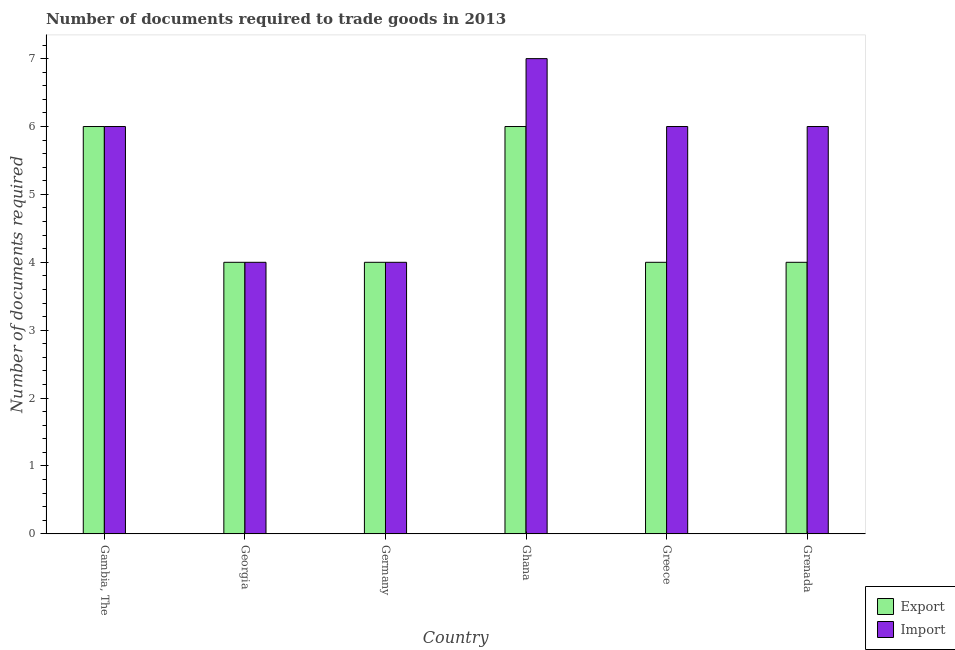How many different coloured bars are there?
Offer a very short reply. 2. Are the number of bars per tick equal to the number of legend labels?
Give a very brief answer. Yes. How many bars are there on the 2nd tick from the right?
Give a very brief answer. 2. What is the label of the 5th group of bars from the left?
Give a very brief answer. Greece. In how many cases, is the number of bars for a given country not equal to the number of legend labels?
Keep it short and to the point. 0. In which country was the number of documents required to export goods maximum?
Keep it short and to the point. Gambia, The. In which country was the number of documents required to import goods minimum?
Offer a terse response. Georgia. What is the difference between the number of documents required to import goods in Gambia, The and the number of documents required to export goods in Greece?
Make the answer very short. 2. What is the average number of documents required to export goods per country?
Your answer should be compact. 4.67. What is the difference between the number of documents required to import goods and number of documents required to export goods in Ghana?
Offer a very short reply. 1. In how many countries, is the number of documents required to import goods greater than 3.6 ?
Offer a terse response. 6. Is the number of documents required to import goods in Germany less than that in Ghana?
Your answer should be compact. Yes. Is the difference between the number of documents required to export goods in Ghana and Grenada greater than the difference between the number of documents required to import goods in Ghana and Grenada?
Give a very brief answer. Yes. In how many countries, is the number of documents required to export goods greater than the average number of documents required to export goods taken over all countries?
Provide a succinct answer. 2. Is the sum of the number of documents required to export goods in Gambia, The and Grenada greater than the maximum number of documents required to import goods across all countries?
Make the answer very short. Yes. What does the 2nd bar from the left in Gambia, The represents?
Offer a very short reply. Import. What does the 1st bar from the right in Ghana represents?
Ensure brevity in your answer.  Import. How many bars are there?
Your answer should be compact. 12. Are all the bars in the graph horizontal?
Your response must be concise. No. What is the difference between two consecutive major ticks on the Y-axis?
Keep it short and to the point. 1. Are the values on the major ticks of Y-axis written in scientific E-notation?
Provide a short and direct response. No. Does the graph contain any zero values?
Provide a succinct answer. No. Where does the legend appear in the graph?
Your response must be concise. Bottom right. How many legend labels are there?
Offer a terse response. 2. How are the legend labels stacked?
Make the answer very short. Vertical. What is the title of the graph?
Your response must be concise. Number of documents required to trade goods in 2013. Does "Female population" appear as one of the legend labels in the graph?
Your response must be concise. No. What is the label or title of the Y-axis?
Your response must be concise. Number of documents required. What is the Number of documents required in Export in Germany?
Ensure brevity in your answer.  4. What is the Number of documents required of Export in Ghana?
Your answer should be compact. 6. What is the Number of documents required in Import in Ghana?
Make the answer very short. 7. What is the Number of documents required of Import in Greece?
Keep it short and to the point. 6. What is the Number of documents required of Export in Grenada?
Your response must be concise. 4. What is the Number of documents required of Import in Grenada?
Keep it short and to the point. 6. Across all countries, what is the maximum Number of documents required of Export?
Ensure brevity in your answer.  6. Across all countries, what is the minimum Number of documents required in Export?
Keep it short and to the point. 4. Across all countries, what is the minimum Number of documents required of Import?
Provide a succinct answer. 4. What is the total Number of documents required in Export in the graph?
Your response must be concise. 28. What is the difference between the Number of documents required in Export in Gambia, The and that in Georgia?
Give a very brief answer. 2. What is the difference between the Number of documents required in Import in Gambia, The and that in Georgia?
Provide a succinct answer. 2. What is the difference between the Number of documents required of Import in Gambia, The and that in Germany?
Provide a short and direct response. 2. What is the difference between the Number of documents required in Export in Gambia, The and that in Ghana?
Ensure brevity in your answer.  0. What is the difference between the Number of documents required of Import in Gambia, The and that in Grenada?
Ensure brevity in your answer.  0. What is the difference between the Number of documents required in Export in Georgia and that in Germany?
Offer a terse response. 0. What is the difference between the Number of documents required in Export in Georgia and that in Ghana?
Your response must be concise. -2. What is the difference between the Number of documents required of Export in Georgia and that in Greece?
Give a very brief answer. 0. What is the difference between the Number of documents required of Export in Georgia and that in Grenada?
Give a very brief answer. 0. What is the difference between the Number of documents required in Import in Germany and that in Ghana?
Ensure brevity in your answer.  -3. What is the difference between the Number of documents required of Import in Germany and that in Greece?
Offer a terse response. -2. What is the difference between the Number of documents required in Export in Ghana and that in Greece?
Make the answer very short. 2. What is the difference between the Number of documents required of Export in Ghana and that in Grenada?
Your answer should be very brief. 2. What is the difference between the Number of documents required of Import in Greece and that in Grenada?
Provide a succinct answer. 0. What is the difference between the Number of documents required in Export in Gambia, The and the Number of documents required in Import in Georgia?
Provide a succinct answer. 2. What is the difference between the Number of documents required in Export in Gambia, The and the Number of documents required in Import in Ghana?
Offer a very short reply. -1. What is the difference between the Number of documents required in Export in Gambia, The and the Number of documents required in Import in Greece?
Offer a terse response. 0. What is the difference between the Number of documents required in Export in Georgia and the Number of documents required in Import in Germany?
Ensure brevity in your answer.  0. What is the difference between the Number of documents required in Export in Georgia and the Number of documents required in Import in Ghana?
Provide a succinct answer. -3. What is the difference between the Number of documents required in Export in Ghana and the Number of documents required in Import in Greece?
Your answer should be very brief. 0. What is the difference between the Number of documents required in Export in Ghana and the Number of documents required in Import in Grenada?
Offer a very short reply. 0. What is the difference between the Number of documents required of Export in Greece and the Number of documents required of Import in Grenada?
Ensure brevity in your answer.  -2. What is the average Number of documents required of Export per country?
Offer a very short reply. 4.67. What is the average Number of documents required of Import per country?
Your answer should be very brief. 5.5. What is the difference between the Number of documents required in Export and Number of documents required in Import in Ghana?
Make the answer very short. -1. What is the difference between the Number of documents required in Export and Number of documents required in Import in Greece?
Offer a very short reply. -2. What is the difference between the Number of documents required of Export and Number of documents required of Import in Grenada?
Provide a short and direct response. -2. What is the ratio of the Number of documents required of Import in Gambia, The to that in Georgia?
Offer a very short reply. 1.5. What is the ratio of the Number of documents required of Export in Gambia, The to that in Germany?
Provide a short and direct response. 1.5. What is the ratio of the Number of documents required in Import in Gambia, The to that in Greece?
Make the answer very short. 1. What is the ratio of the Number of documents required in Export in Gambia, The to that in Grenada?
Offer a terse response. 1.5. What is the ratio of the Number of documents required of Import in Gambia, The to that in Grenada?
Make the answer very short. 1. What is the ratio of the Number of documents required of Import in Georgia to that in Germany?
Make the answer very short. 1. What is the ratio of the Number of documents required in Export in Georgia to that in Ghana?
Keep it short and to the point. 0.67. What is the ratio of the Number of documents required of Import in Georgia to that in Ghana?
Give a very brief answer. 0.57. What is the ratio of the Number of documents required of Export in Georgia to that in Grenada?
Provide a succinct answer. 1. What is the ratio of the Number of documents required of Import in Georgia to that in Grenada?
Your answer should be very brief. 0.67. What is the ratio of the Number of documents required in Export in Ghana to that in Greece?
Your answer should be very brief. 1.5. What is the ratio of the Number of documents required in Import in Ghana to that in Grenada?
Keep it short and to the point. 1.17. What is the difference between the highest and the second highest Number of documents required of Export?
Your response must be concise. 0. 